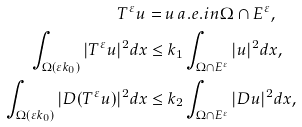<formula> <loc_0><loc_0><loc_500><loc_500>T ^ { \varepsilon } u = \, & u \, a . e . i n \Omega \cap E ^ { \varepsilon } , \\ \int _ { \Omega ( \varepsilon k _ { 0 } ) } | T ^ { \varepsilon } u | ^ { 2 } d x \leq & \, k _ { 1 } \int _ { \Omega \cap E ^ { \varepsilon } } | u | ^ { 2 } d x , \\ \int _ { \Omega ( \varepsilon k _ { 0 } ) } | D ( T ^ { \varepsilon } u ) | ^ { 2 } d x \leq & \, k _ { 2 } \int _ { \Omega \cap E ^ { \varepsilon } } | D u | ^ { 2 } d x ,</formula> 